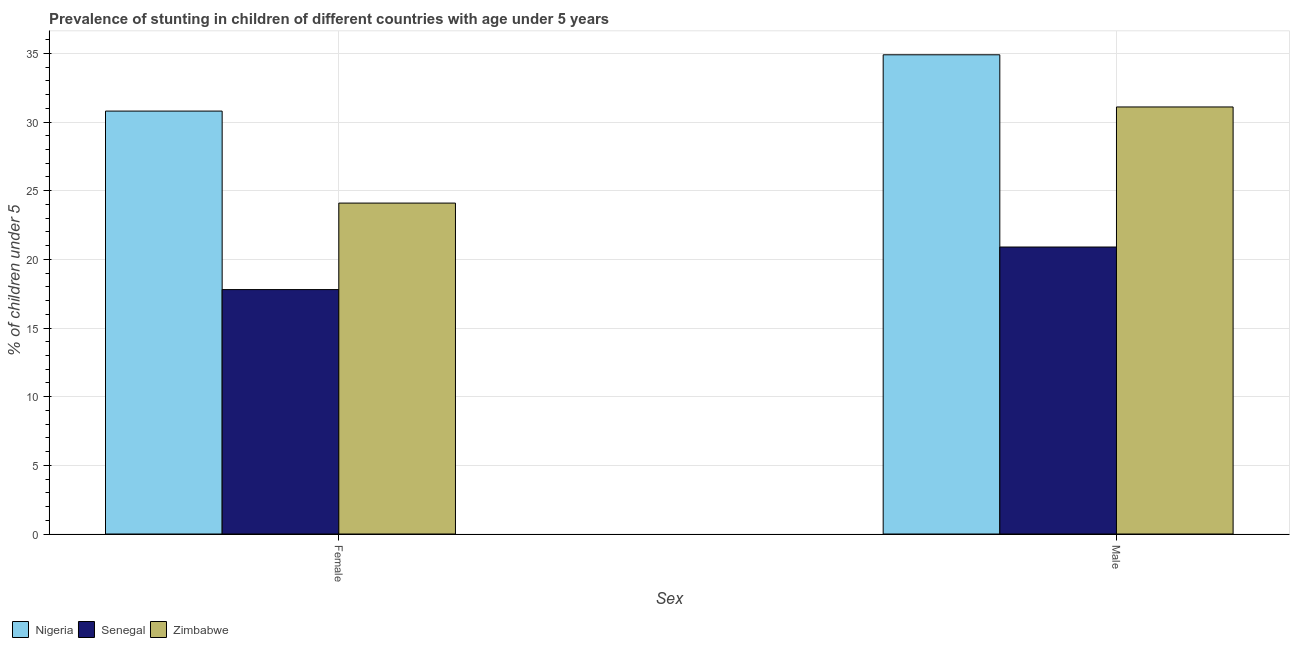How many different coloured bars are there?
Provide a short and direct response. 3. How many groups of bars are there?
Offer a terse response. 2. Are the number of bars per tick equal to the number of legend labels?
Your answer should be very brief. Yes. Are the number of bars on each tick of the X-axis equal?
Your answer should be very brief. Yes. How many bars are there on the 2nd tick from the right?
Keep it short and to the point. 3. What is the percentage of stunted female children in Nigeria?
Your answer should be compact. 30.8. Across all countries, what is the maximum percentage of stunted female children?
Your answer should be very brief. 30.8. Across all countries, what is the minimum percentage of stunted male children?
Provide a succinct answer. 20.9. In which country was the percentage of stunted male children maximum?
Your answer should be very brief. Nigeria. In which country was the percentage of stunted female children minimum?
Ensure brevity in your answer.  Senegal. What is the total percentage of stunted male children in the graph?
Offer a very short reply. 86.9. What is the difference between the percentage of stunted male children in Nigeria and that in Zimbabwe?
Offer a very short reply. 3.8. What is the difference between the percentage of stunted female children in Zimbabwe and the percentage of stunted male children in Senegal?
Your answer should be very brief. 3.2. What is the average percentage of stunted female children per country?
Your answer should be compact. 24.23. What is the ratio of the percentage of stunted male children in Zimbabwe to that in Nigeria?
Ensure brevity in your answer.  0.89. In how many countries, is the percentage of stunted male children greater than the average percentage of stunted male children taken over all countries?
Your answer should be very brief. 2. What does the 3rd bar from the left in Male represents?
Make the answer very short. Zimbabwe. What does the 2nd bar from the right in Male represents?
Your answer should be very brief. Senegal. How many bars are there?
Provide a short and direct response. 6. Are all the bars in the graph horizontal?
Provide a short and direct response. No. How many countries are there in the graph?
Your response must be concise. 3. Are the values on the major ticks of Y-axis written in scientific E-notation?
Your answer should be compact. No. Does the graph contain any zero values?
Your answer should be very brief. No. Does the graph contain grids?
Your response must be concise. Yes. Where does the legend appear in the graph?
Offer a terse response. Bottom left. How many legend labels are there?
Provide a short and direct response. 3. What is the title of the graph?
Your answer should be very brief. Prevalence of stunting in children of different countries with age under 5 years. What is the label or title of the X-axis?
Your answer should be very brief. Sex. What is the label or title of the Y-axis?
Provide a short and direct response.  % of children under 5. What is the  % of children under 5 of Nigeria in Female?
Your answer should be very brief. 30.8. What is the  % of children under 5 of Senegal in Female?
Keep it short and to the point. 17.8. What is the  % of children under 5 of Zimbabwe in Female?
Keep it short and to the point. 24.1. What is the  % of children under 5 of Nigeria in Male?
Provide a succinct answer. 34.9. What is the  % of children under 5 of Senegal in Male?
Keep it short and to the point. 20.9. What is the  % of children under 5 of Zimbabwe in Male?
Your answer should be very brief. 31.1. Across all Sex, what is the maximum  % of children under 5 in Nigeria?
Provide a short and direct response. 34.9. Across all Sex, what is the maximum  % of children under 5 in Senegal?
Provide a short and direct response. 20.9. Across all Sex, what is the maximum  % of children under 5 of Zimbabwe?
Your answer should be very brief. 31.1. Across all Sex, what is the minimum  % of children under 5 in Nigeria?
Offer a terse response. 30.8. Across all Sex, what is the minimum  % of children under 5 of Senegal?
Offer a very short reply. 17.8. Across all Sex, what is the minimum  % of children under 5 in Zimbabwe?
Give a very brief answer. 24.1. What is the total  % of children under 5 in Nigeria in the graph?
Your answer should be very brief. 65.7. What is the total  % of children under 5 of Senegal in the graph?
Your response must be concise. 38.7. What is the total  % of children under 5 in Zimbabwe in the graph?
Keep it short and to the point. 55.2. What is the difference between the  % of children under 5 in Nigeria in Female and that in Male?
Offer a very short reply. -4.1. What is the difference between the  % of children under 5 in Nigeria in Female and the  % of children under 5 in Zimbabwe in Male?
Your answer should be very brief. -0.3. What is the difference between the  % of children under 5 of Senegal in Female and the  % of children under 5 of Zimbabwe in Male?
Your answer should be compact. -13.3. What is the average  % of children under 5 of Nigeria per Sex?
Ensure brevity in your answer.  32.85. What is the average  % of children under 5 in Senegal per Sex?
Ensure brevity in your answer.  19.35. What is the average  % of children under 5 of Zimbabwe per Sex?
Offer a terse response. 27.6. What is the difference between the  % of children under 5 of Senegal and  % of children under 5 of Zimbabwe in Female?
Your answer should be very brief. -6.3. What is the difference between the  % of children under 5 in Nigeria and  % of children under 5 in Senegal in Male?
Give a very brief answer. 14. What is the difference between the  % of children under 5 of Senegal and  % of children under 5 of Zimbabwe in Male?
Your response must be concise. -10.2. What is the ratio of the  % of children under 5 of Nigeria in Female to that in Male?
Offer a terse response. 0.88. What is the ratio of the  % of children under 5 of Senegal in Female to that in Male?
Offer a terse response. 0.85. What is the ratio of the  % of children under 5 in Zimbabwe in Female to that in Male?
Give a very brief answer. 0.77. What is the difference between the highest and the second highest  % of children under 5 of Senegal?
Your answer should be compact. 3.1. What is the difference between the highest and the lowest  % of children under 5 of Senegal?
Provide a succinct answer. 3.1. 